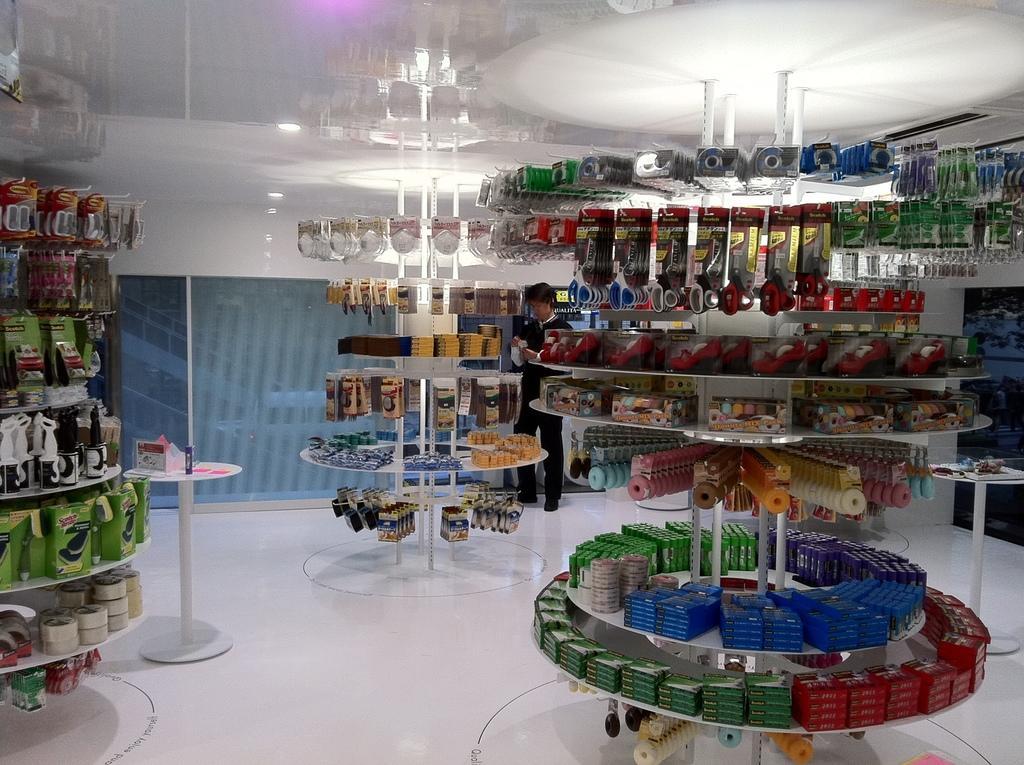How would you summarize this image in a sentence or two? In the image it looks like there are chocolates, grocery items, stationary objects and many other things in a store and in the background there is a man standing in front of a glass window. 